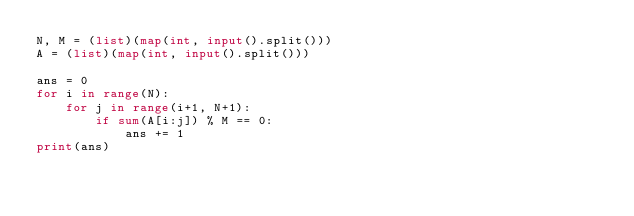Convert code to text. <code><loc_0><loc_0><loc_500><loc_500><_Python_>N, M = (list)(map(int, input().split()))
A = (list)(map(int, input().split()))

ans = 0
for i in range(N):
    for j in range(i+1, N+1):
        if sum(A[i:j]) % M == 0:
            ans += 1
print(ans)
</code> 